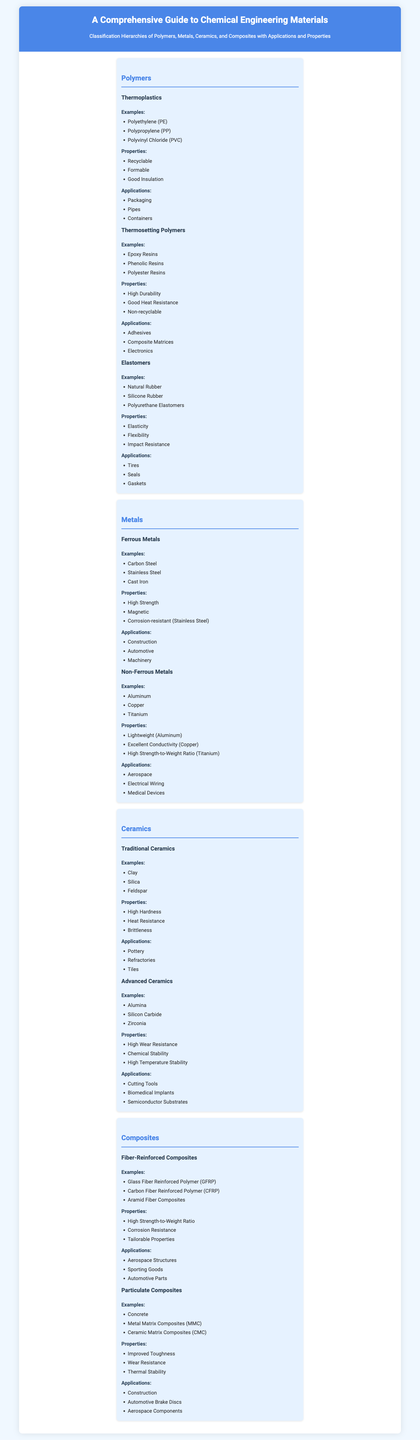What are the three types of polymers listed? The document lists three types of polymers: Thermoplastics, Thermosetting Polymers, and Elastomers.
Answer: Thermoplastics, Thermosetting Polymers, Elastomers What is one application of thermoplastic materials? The document mentions several applications; one of which is Packaging.
Answer: Packaging Which metal is known for excellent conductivity? The document states that Copper is known for its excellent conductivity.
Answer: Copper What property is associated with fiber-reinforced composites? One of the properties listed for fiber-reinforced composites is High Strength-to-Weight Ratio.
Answer: High Strength-to-Weight Ratio How many examples of traditional ceramics are provided? The document provides three examples of traditional ceramics: Clay, Silica, and Feldspar.
Answer: Three What type of metal is Titanium classified as? Based on the content, Titanium is classified as a Non-Ferrous Metal.
Answer: Non-Ferrous Metal What are the two categories of composites listed? The categories of composites listed are Fiber-Reinforced Composites and Particulate Composites.
Answer: Fiber-Reinforced Composites, Particulate Composites Which polymer type is known for high durability? The document states that Thermosetting Polymers are known for high durability.
Answer: Thermosetting Polymers What application is associated with natural rubber? The document mentions Tires as an application associated with natural rubber.
Answer: Tires 